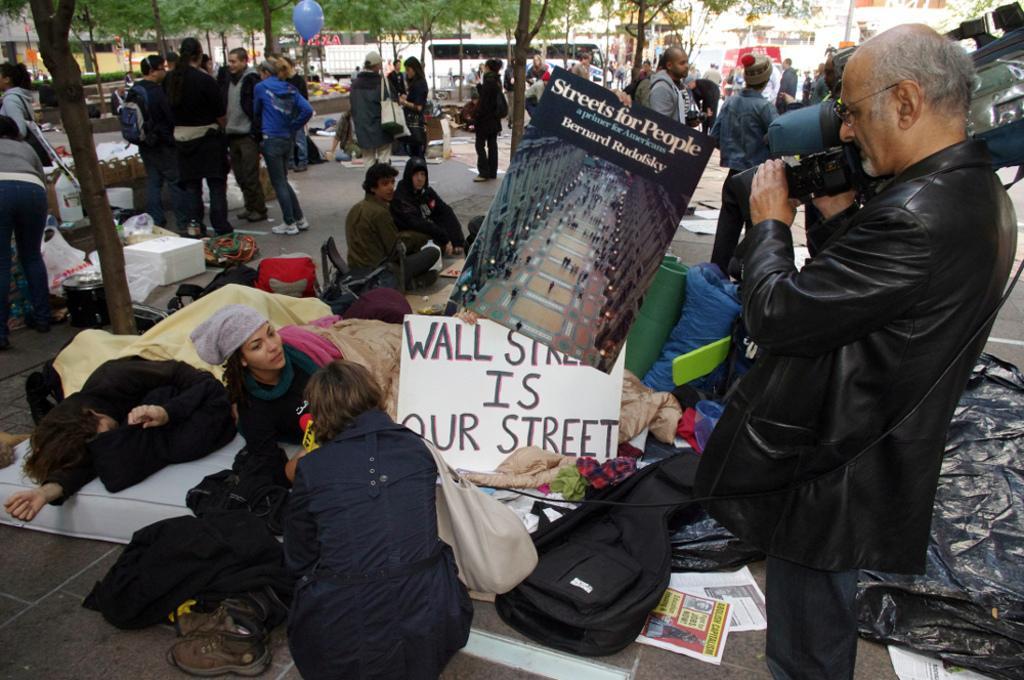How would you summarize this image in a sentence or two? In this picture we can see a group of people, bags, shoes, clothes, posters, camera, balloon, boxes, vehicles, some objects and in the background we can see buildings, trees. 